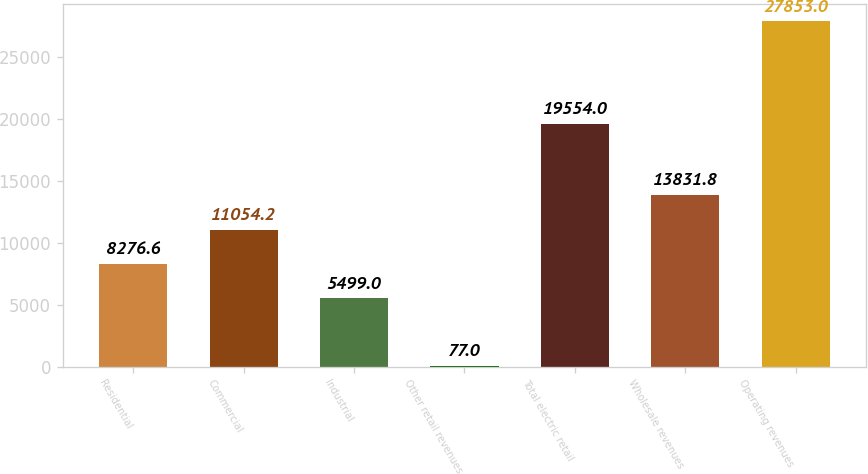Convert chart. <chart><loc_0><loc_0><loc_500><loc_500><bar_chart><fcel>Residential<fcel>Commercial<fcel>Industrial<fcel>Other retail revenues<fcel>Total electric retail<fcel>Wholesale revenues<fcel>Operating revenues<nl><fcel>8276.6<fcel>11054.2<fcel>5499<fcel>77<fcel>19554<fcel>13831.8<fcel>27853<nl></chart> 